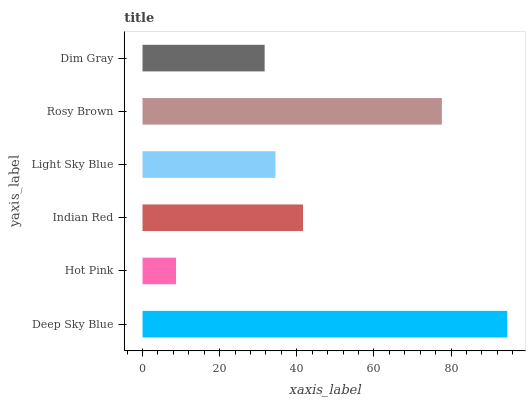Is Hot Pink the minimum?
Answer yes or no. Yes. Is Deep Sky Blue the maximum?
Answer yes or no. Yes. Is Indian Red the minimum?
Answer yes or no. No. Is Indian Red the maximum?
Answer yes or no. No. Is Indian Red greater than Hot Pink?
Answer yes or no. Yes. Is Hot Pink less than Indian Red?
Answer yes or no. Yes. Is Hot Pink greater than Indian Red?
Answer yes or no. No. Is Indian Red less than Hot Pink?
Answer yes or no. No. Is Indian Red the high median?
Answer yes or no. Yes. Is Light Sky Blue the low median?
Answer yes or no. Yes. Is Deep Sky Blue the high median?
Answer yes or no. No. Is Deep Sky Blue the low median?
Answer yes or no. No. 